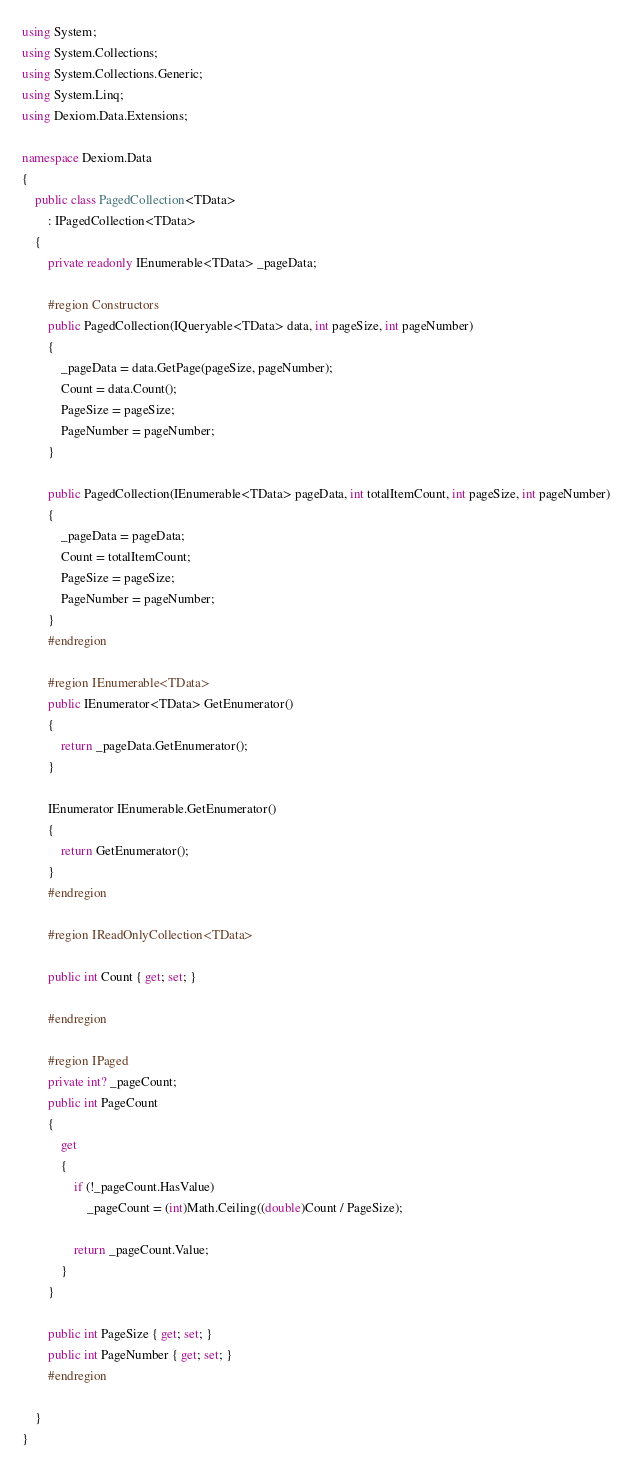Convert code to text. <code><loc_0><loc_0><loc_500><loc_500><_C#_>using System;
using System.Collections;
using System.Collections.Generic;
using System.Linq;
using Dexiom.Data.Extensions;

namespace Dexiom.Data
{
    public class PagedCollection<TData>
        : IPagedCollection<TData>
    {
        private readonly IEnumerable<TData> _pageData;

        #region Constructors
        public PagedCollection(IQueryable<TData> data, int pageSize, int pageNumber)
        {
            _pageData = data.GetPage(pageSize, pageNumber);
            Count = data.Count();
            PageSize = pageSize;
            PageNumber = pageNumber;
        }
        
        public PagedCollection(IEnumerable<TData> pageData, int totalItemCount, int pageSize, int pageNumber)
        {
            _pageData = pageData;
            Count = totalItemCount;
            PageSize = pageSize;
            PageNumber = pageNumber;
        }
        #endregion

        #region IEnumerable<TData>
        public IEnumerator<TData> GetEnumerator()
        {
            return _pageData.GetEnumerator();
        }

        IEnumerator IEnumerable.GetEnumerator()
        {
            return GetEnumerator();
        }
        #endregion

        #region IReadOnlyCollection<TData>

        public int Count { get; set; }

        #endregion

        #region IPaged
        private int? _pageCount;
        public int PageCount
        {
            get
            {
                if (!_pageCount.HasValue)
                    _pageCount = (int)Math.Ceiling((double)Count / PageSize);

                return _pageCount.Value;
            }
        }
        
        public int PageSize { get; set; }
        public int PageNumber { get; set; }
        #endregion

    }
}</code> 